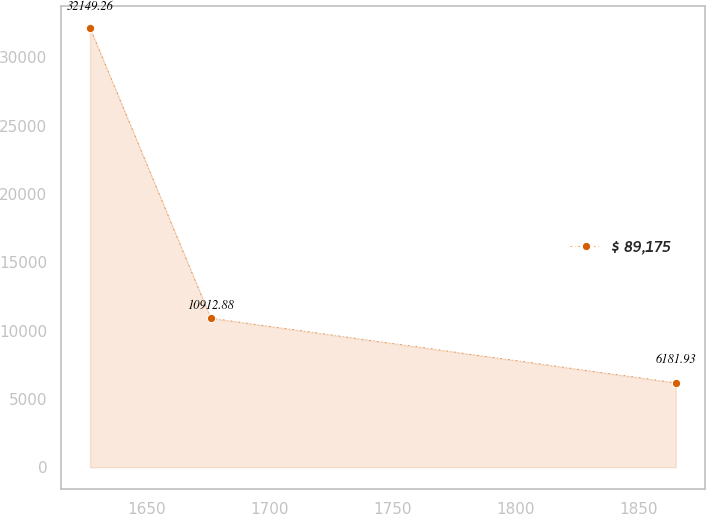Convert chart to OTSL. <chart><loc_0><loc_0><loc_500><loc_500><line_chart><ecel><fcel>$ 89,175<nl><fcel>1626.78<fcel>32149.3<nl><fcel>1675.91<fcel>10912.9<nl><fcel>1864.99<fcel>6181.93<nl></chart> 